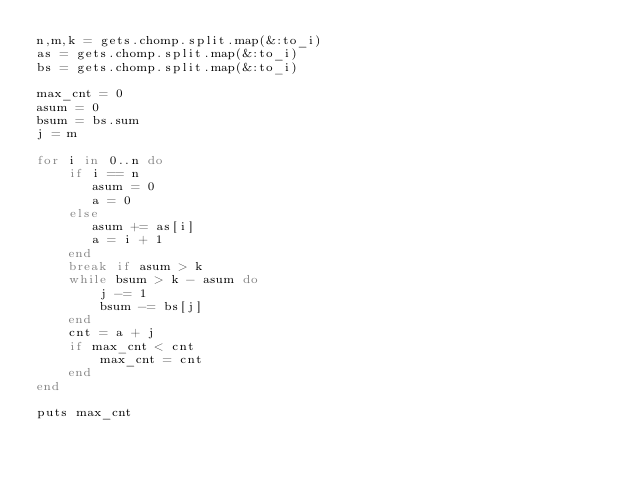<code> <loc_0><loc_0><loc_500><loc_500><_Ruby_>n,m,k = gets.chomp.split.map(&:to_i)
as = gets.chomp.split.map(&:to_i)
bs = gets.chomp.split.map(&:to_i)

max_cnt = 0
asum = 0
bsum = bs.sum
j = m

for i in 0..n do
    if i == n
       asum = 0
       a = 0
    else
       asum += as[i]
       a = i + 1
    end
    break if asum > k
    while bsum > k - asum do
        j -= 1
        bsum -= bs[j]
    end
    cnt = a + j
    if max_cnt < cnt
        max_cnt = cnt
    end
end

puts max_cnt</code> 